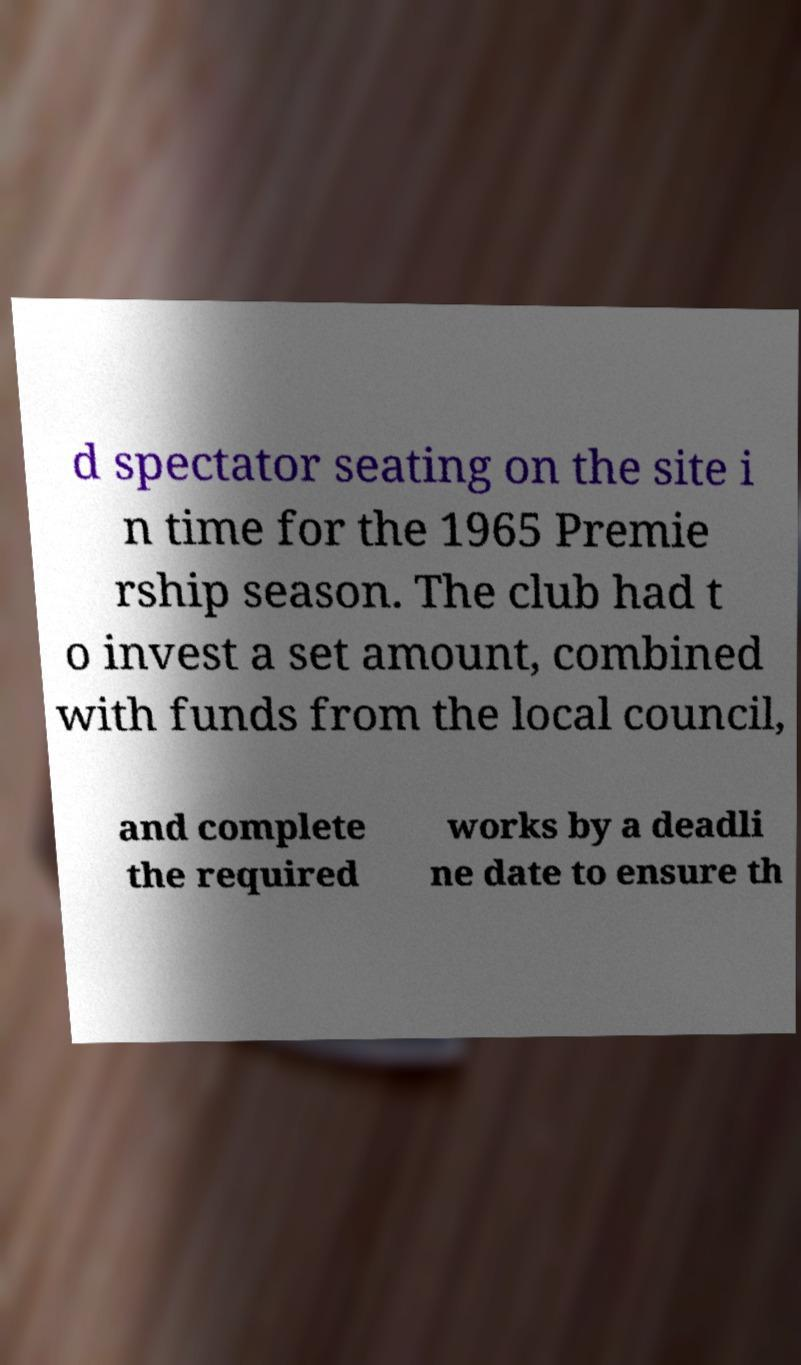For documentation purposes, I need the text within this image transcribed. Could you provide that? d spectator seating on the site i n time for the 1965 Premie rship season. The club had t o invest a set amount, combined with funds from the local council, and complete the required works by a deadli ne date to ensure th 